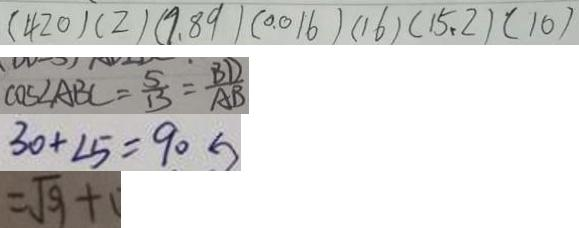<formula> <loc_0><loc_0><loc_500><loc_500>( 4 2 0 ) ( 2 ) ( 9 . 8 9 ) ( 0 . 0 1 6 ) ( 1 6 ) ( 1 5 . 2 ) ( 1 0 ) 
 C O E \angle A B C = \frac { 5 } { 1 3 } = \frac { B D } { A B } 
 3 0 + \angle 5 = 9 0 
 = \sqrt { 9 } +</formula> 